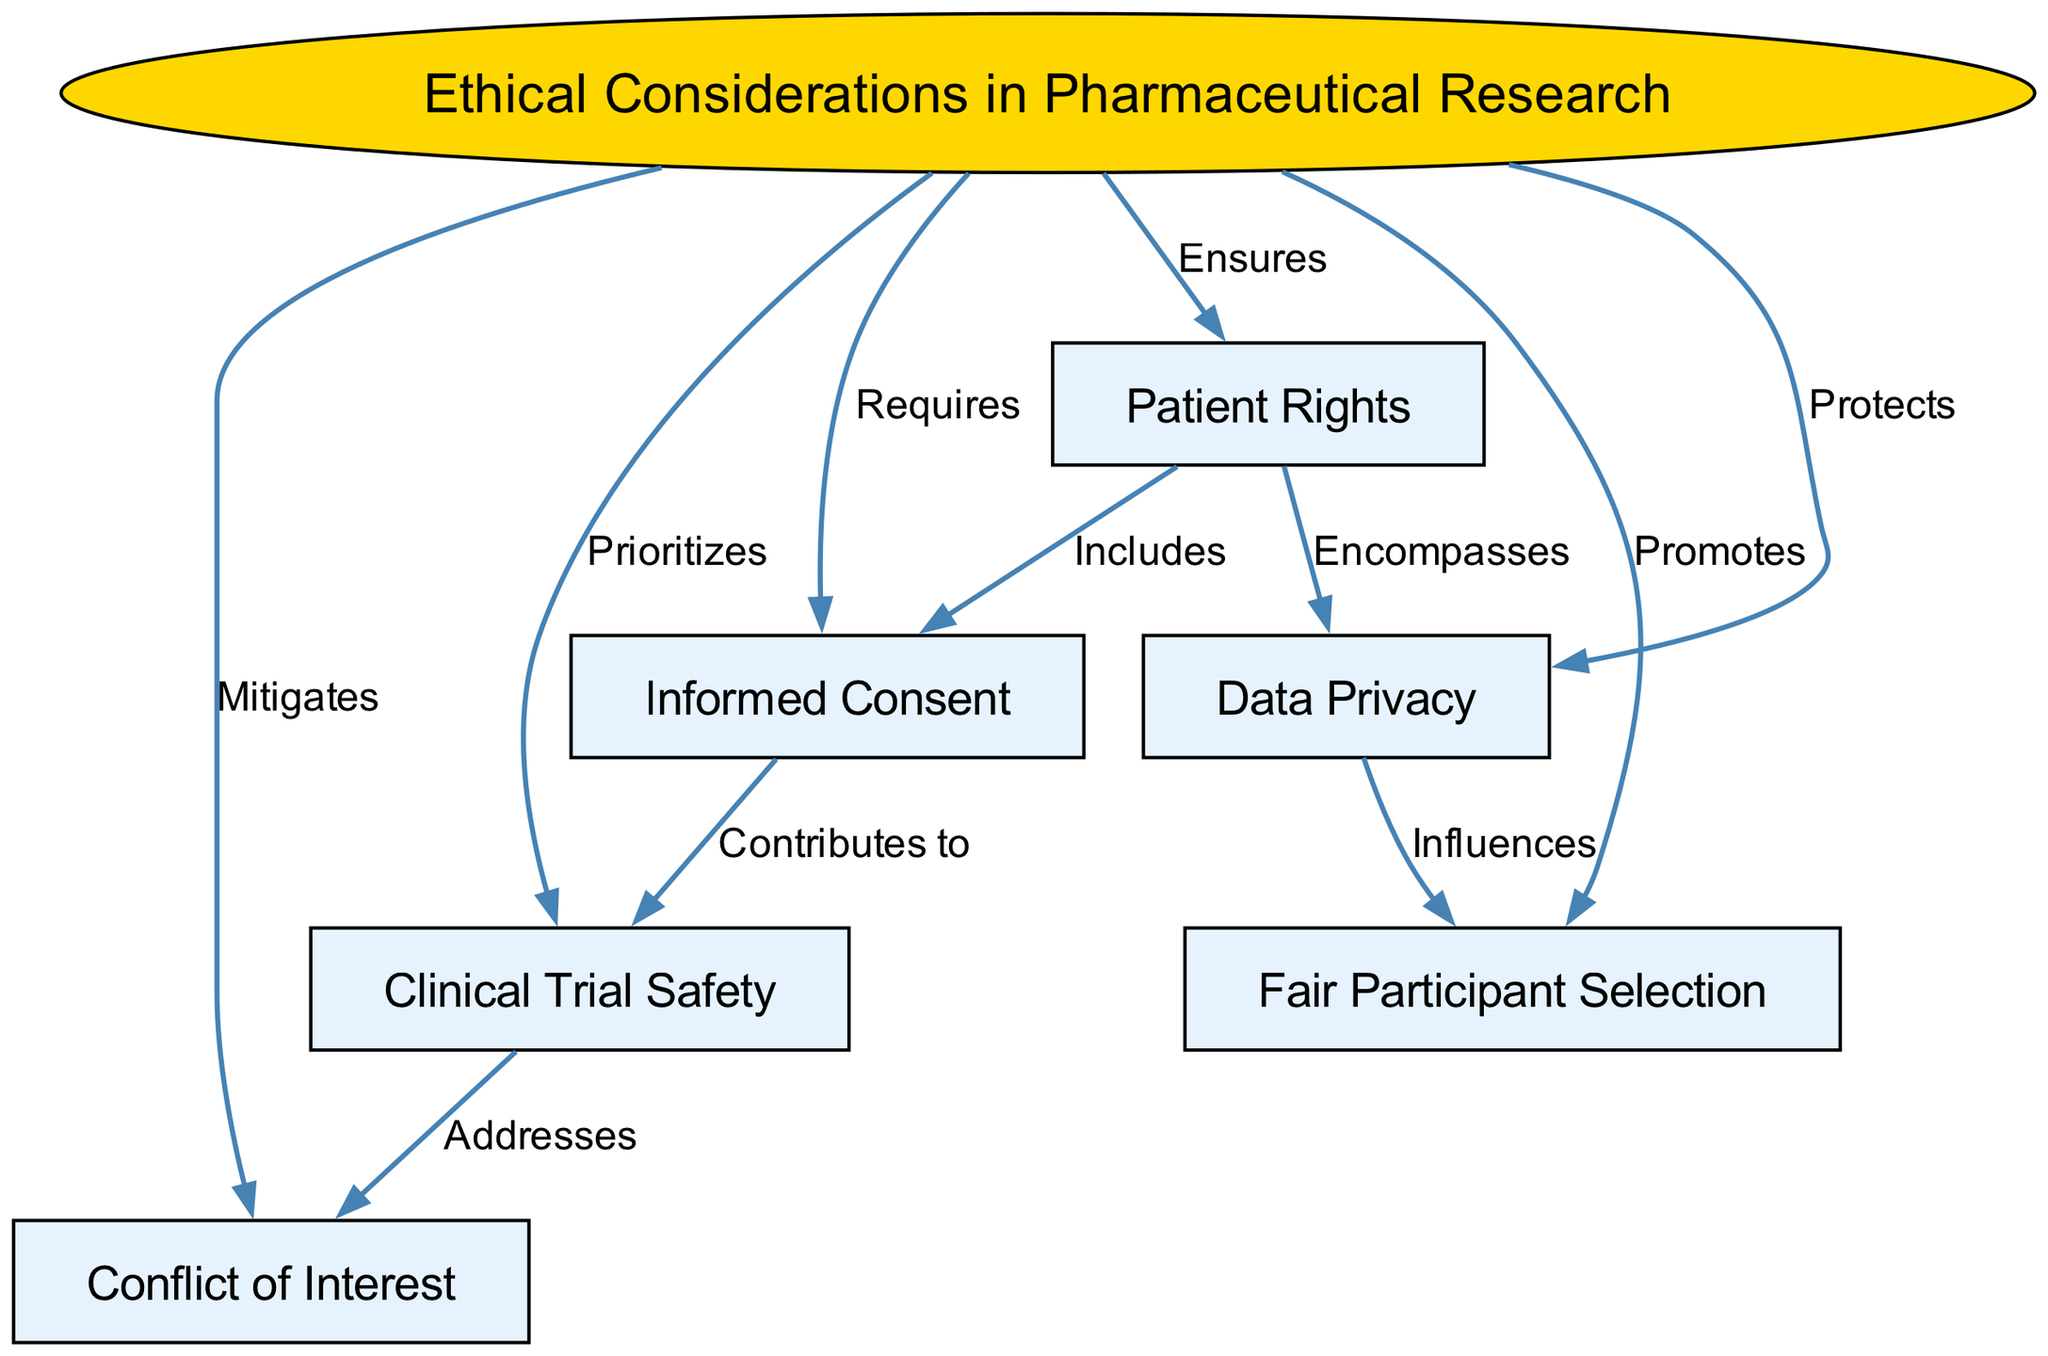What is the main topic of the diagram? The main topic is stated in the first node labeled "Ethical Considerations in Pharmaceutical Research." It encapsulates the overall focus of the diagram.
Answer: Ethical Considerations in Pharmaceutical Research How many nodes are there in total? By counting the nodes listed in the data, we can see that there are a total of 7 nodes present in the diagram.
Answer: 7 What does "Patient Rights" ensure? The diagram shows an edge labeled "Ensures" connecting "Ethical Considerations in Pharmaceutical Research" to "Patient Rights," which indicates that the aspect of patient rights is ensured within the ethical framework.
Answer: Ensures What does "Informed Consent" contribute to? The relationship shown between "Informed Consent" and "Clinical Trial Safety" through the edge labeled "Contributes to" indicates that informed consent plays a role in enhancing clinical trial safety.
Answer: Contributes to What influence does "Data Privacy" have? The edge labeled "Influences" connects "Data Privacy" to "Fair Participant Selection," indicating that data privacy considerations influence how participants are selected for trials.
Answer: Influences How does "Conflict of Interest" relate to clinical trial safety? "Conflict of Interest" is connected to "Clinical Trial Safety" with the edge labeled "Addresses," suggesting that attention to conflicts of interest helps ensure safety in clinical trials.
Answer: Addresses What ethical aspect promotes "Fair Participant Selection"? The connection from the main node "Ethical Considerations in Pharmaceutical Research" to "Fair Participant Selection" is labeled "Promotes," indicating that overall ethical considerations encourage fair selection practices.
Answer: Promotes Which node includes both "Patient Rights" and "Data Privacy"? The edge labeled "Encompasses" shows that "Patient Rights" is related to "Data Privacy," making "Patient Rights" the node that includes the considerations of data privacy.
Answer: Encompasses 